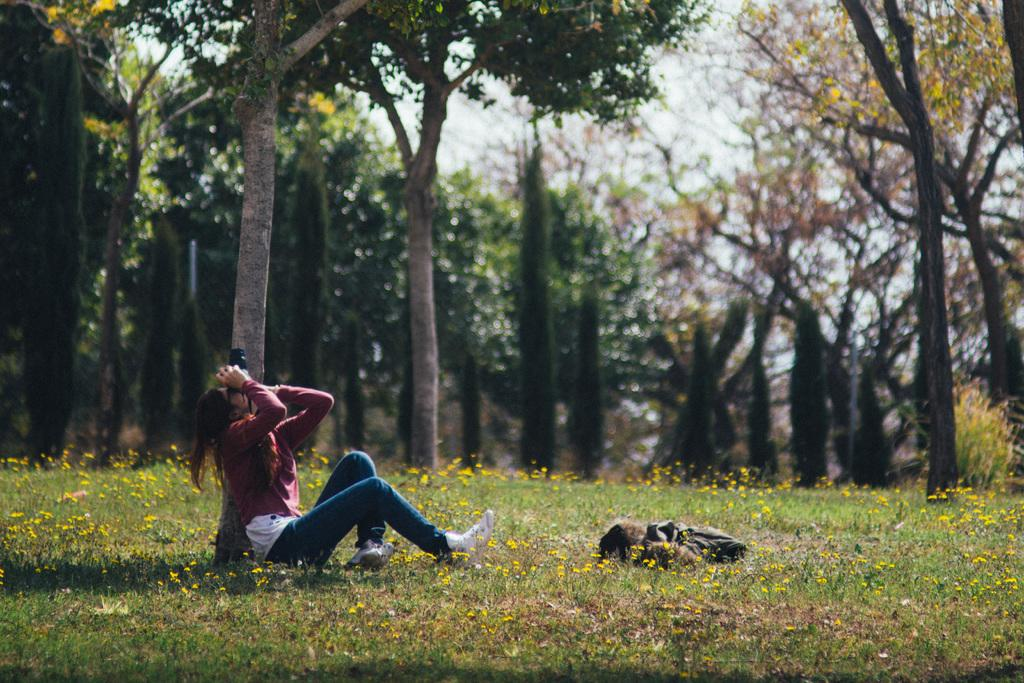Who is the main subject in the image? There is a lady in the image. What is the lady holding in the image? The lady is holding a camera. What type of vegetation can be seen at the bottom of the image? There is grass and plants at the bottom of the image. What can be seen in the background of the image? There are trees in the background of the image. What else is present in the image besides the lady and the camera? There is a bag in the image. What type of milk is being poured into the bag in the image? There is no milk or pouring action present in the image. How does the lady's breath affect the camera in the image? There is no mention of the lady's breath affecting the camera in the image. 